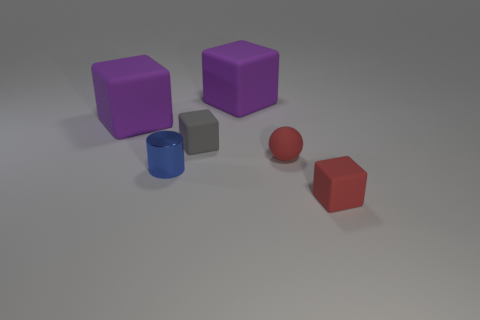Add 1 big gray shiny spheres. How many objects exist? 7 Subtract all balls. How many objects are left? 5 Add 3 small blue metallic objects. How many small blue metallic objects are left? 4 Add 4 tiny gray rubber blocks. How many tiny gray rubber blocks exist? 5 Subtract 1 gray blocks. How many objects are left? 5 Subtract all cyan blocks. Subtract all red blocks. How many objects are left? 5 